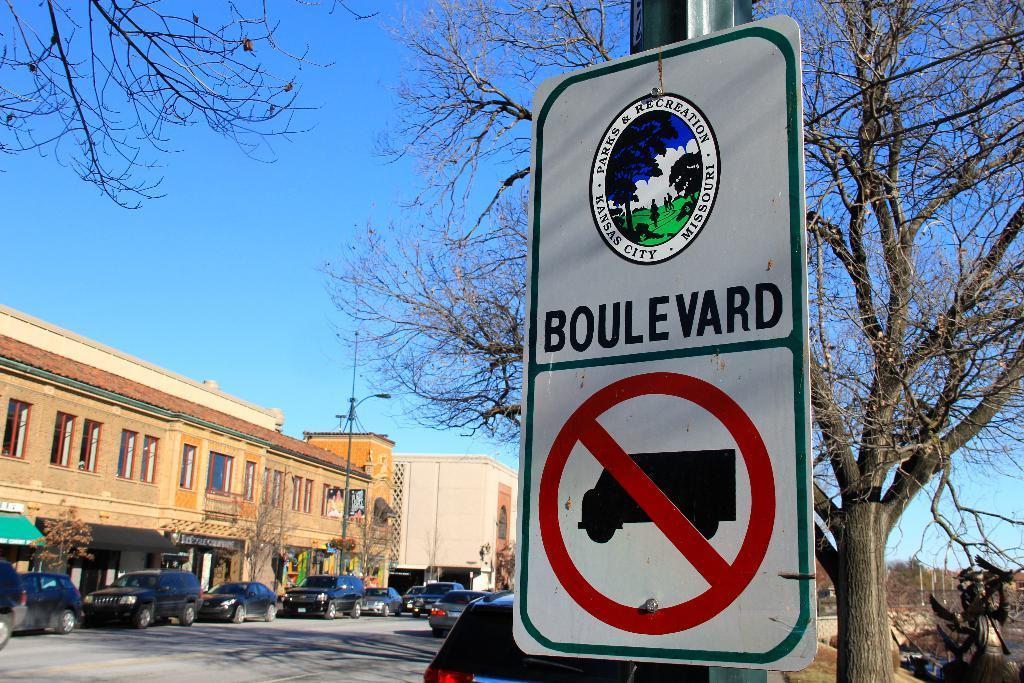Provide a one-sentence caption for the provided image. Road sign that says Boulevard and no trucks. 